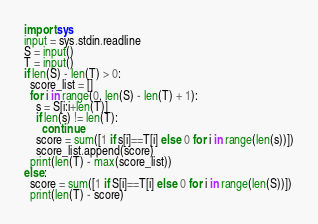<code> <loc_0><loc_0><loc_500><loc_500><_Python_>import sys
input = sys.stdin.readline
S = input()
T = input()
if len(S) - len(T) > 0:
  score_list = []
  for i in range(0, len(S) - len(T) + 1):
    s = S[i:i+len(T)]
    if len(s) != len(T):
      continue
    score = sum([1 if s[i]==T[i] else 0 for i in range(len(s))])
    score_list.append(score)
  print(len(T) - max(score_list))
else:
  score = sum([1 if S[i]==T[i] else 0 for i in range(len(S))])
  print(len(T) - score)</code> 